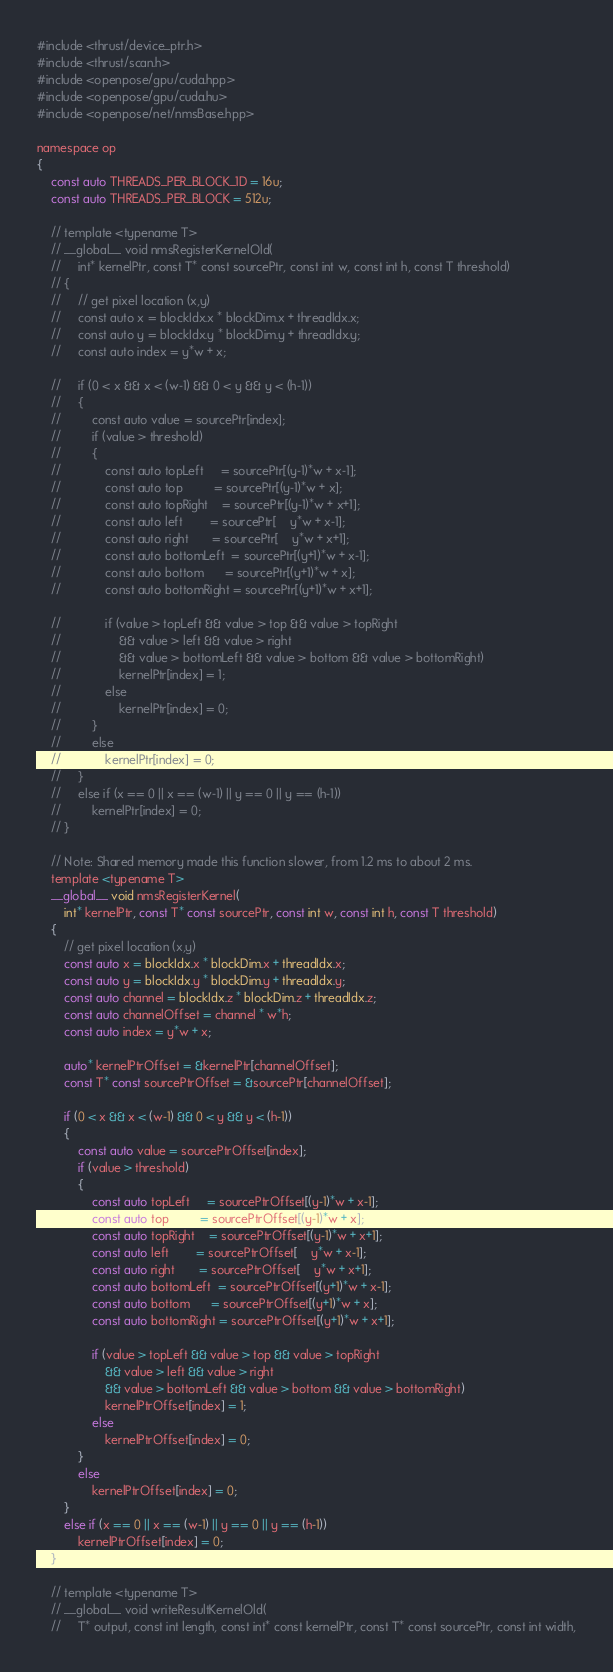<code> <loc_0><loc_0><loc_500><loc_500><_Cuda_>#include <thrust/device_ptr.h>
#include <thrust/scan.h>
#include <openpose/gpu/cuda.hpp>
#include <openpose/gpu/cuda.hu>
#include <openpose/net/nmsBase.hpp>

namespace op
{
    const auto THREADS_PER_BLOCK_1D = 16u;
    const auto THREADS_PER_BLOCK = 512u;

    // template <typename T>
    // __global__ void nmsRegisterKernelOld(
    //     int* kernelPtr, const T* const sourcePtr, const int w, const int h, const T threshold)
    // {
    //     // get pixel location (x,y)
    //     const auto x = blockIdx.x * blockDim.x + threadIdx.x;
    //     const auto y = blockIdx.y * blockDim.y + threadIdx.y;
    //     const auto index = y*w + x;

    //     if (0 < x && x < (w-1) && 0 < y && y < (h-1))
    //     {
    //         const auto value = sourcePtr[index];
    //         if (value > threshold)
    //         {
    //             const auto topLeft     = sourcePtr[(y-1)*w + x-1];
    //             const auto top         = sourcePtr[(y-1)*w + x];
    //             const auto topRight    = sourcePtr[(y-1)*w + x+1];
    //             const auto left        = sourcePtr[    y*w + x-1];
    //             const auto right       = sourcePtr[    y*w + x+1];
    //             const auto bottomLeft  = sourcePtr[(y+1)*w + x-1];
    //             const auto bottom      = sourcePtr[(y+1)*w + x];
    //             const auto bottomRight = sourcePtr[(y+1)*w + x+1];

    //             if (value > topLeft && value > top && value > topRight
    //                 && value > left && value > right
    //                 && value > bottomLeft && value > bottom && value > bottomRight)
    //                 kernelPtr[index] = 1;
    //             else
    //                 kernelPtr[index] = 0;
    //         }
    //         else
    //             kernelPtr[index] = 0;
    //     }
    //     else if (x == 0 || x == (w-1) || y == 0 || y == (h-1))
    //         kernelPtr[index] = 0;
    // }

    // Note: Shared memory made this function slower, from 1.2 ms to about 2 ms.
    template <typename T>
    __global__ void nmsRegisterKernel(
        int* kernelPtr, const T* const sourcePtr, const int w, const int h, const T threshold)
    {
        // get pixel location (x,y)
        const auto x = blockIdx.x * blockDim.x + threadIdx.x;
        const auto y = blockIdx.y * blockDim.y + threadIdx.y;
        const auto channel = blockIdx.z * blockDim.z + threadIdx.z;
        const auto channelOffset = channel * w*h;
        const auto index = y*w + x;

        auto* kernelPtrOffset = &kernelPtr[channelOffset];
        const T* const sourcePtrOffset = &sourcePtr[channelOffset];

        if (0 < x && x < (w-1) && 0 < y && y < (h-1))
        {
            const auto value = sourcePtrOffset[index];
            if (value > threshold)
            {
                const auto topLeft     = sourcePtrOffset[(y-1)*w + x-1];
                const auto top         = sourcePtrOffset[(y-1)*w + x];
                const auto topRight    = sourcePtrOffset[(y-1)*w + x+1];
                const auto left        = sourcePtrOffset[    y*w + x-1];
                const auto right       = sourcePtrOffset[    y*w + x+1];
                const auto bottomLeft  = sourcePtrOffset[(y+1)*w + x-1];
                const auto bottom      = sourcePtrOffset[(y+1)*w + x];
                const auto bottomRight = sourcePtrOffset[(y+1)*w + x+1];

                if (value > topLeft && value > top && value > topRight
                    && value > left && value > right
                    && value > bottomLeft && value > bottom && value > bottomRight)
                    kernelPtrOffset[index] = 1;
                else
                    kernelPtrOffset[index] = 0;
            }
            else
                kernelPtrOffset[index] = 0;
        }
        else if (x == 0 || x == (w-1) || y == 0 || y == (h-1))
            kernelPtrOffset[index] = 0;
    }

    // template <typename T>
    // __global__ void writeResultKernelOld(
    //     T* output, const int length, const int* const kernelPtr, const T* const sourcePtr, const int width,</code> 